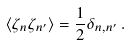<formula> <loc_0><loc_0><loc_500><loc_500>\langle \zeta _ { n } \zeta _ { n ^ { \prime } } \rangle = \frac { 1 } { 2 } \delta _ { n , n ^ { \prime } } \, .</formula> 